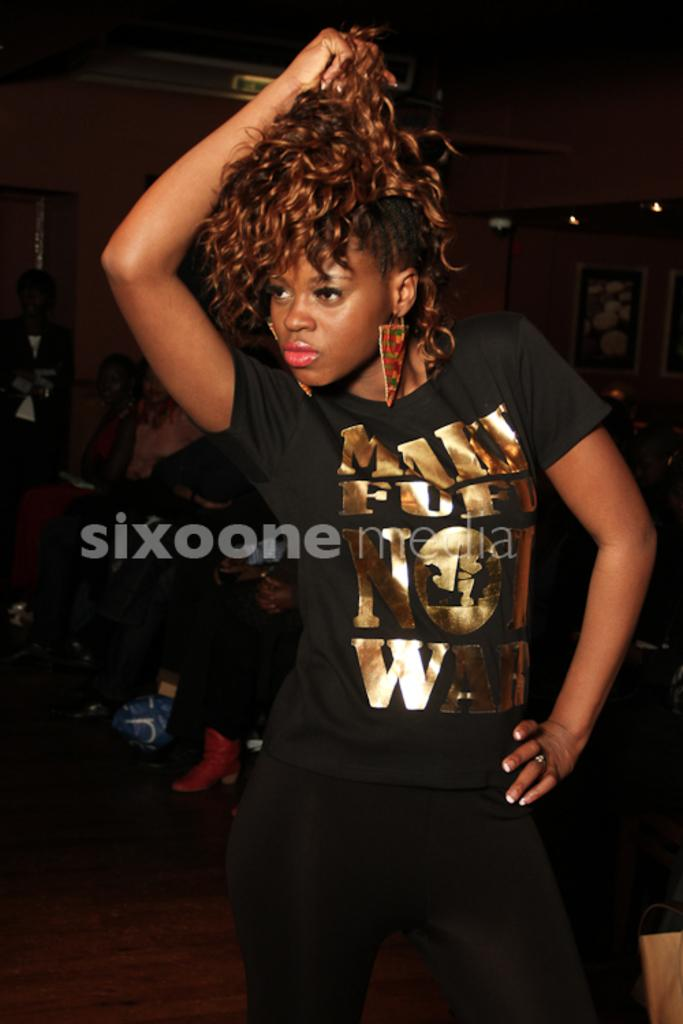Who is the main subject in the image? There is a girl in the image. What is the girl wearing? The girl is wearing a black dress. Where is the girl positioned in the image? The girl is standing on the floor. What can be seen in the background of the image? There is a group of people sitting and photo frames visible in the background. What else is present in the background? There are lights visible in the background. How many keys are the women holding in the image? There are no women or keys present in the image; it features a girl wearing a black dress and standing on the floor. What type of oranges can be seen in the image? There are no oranges present in the image. 